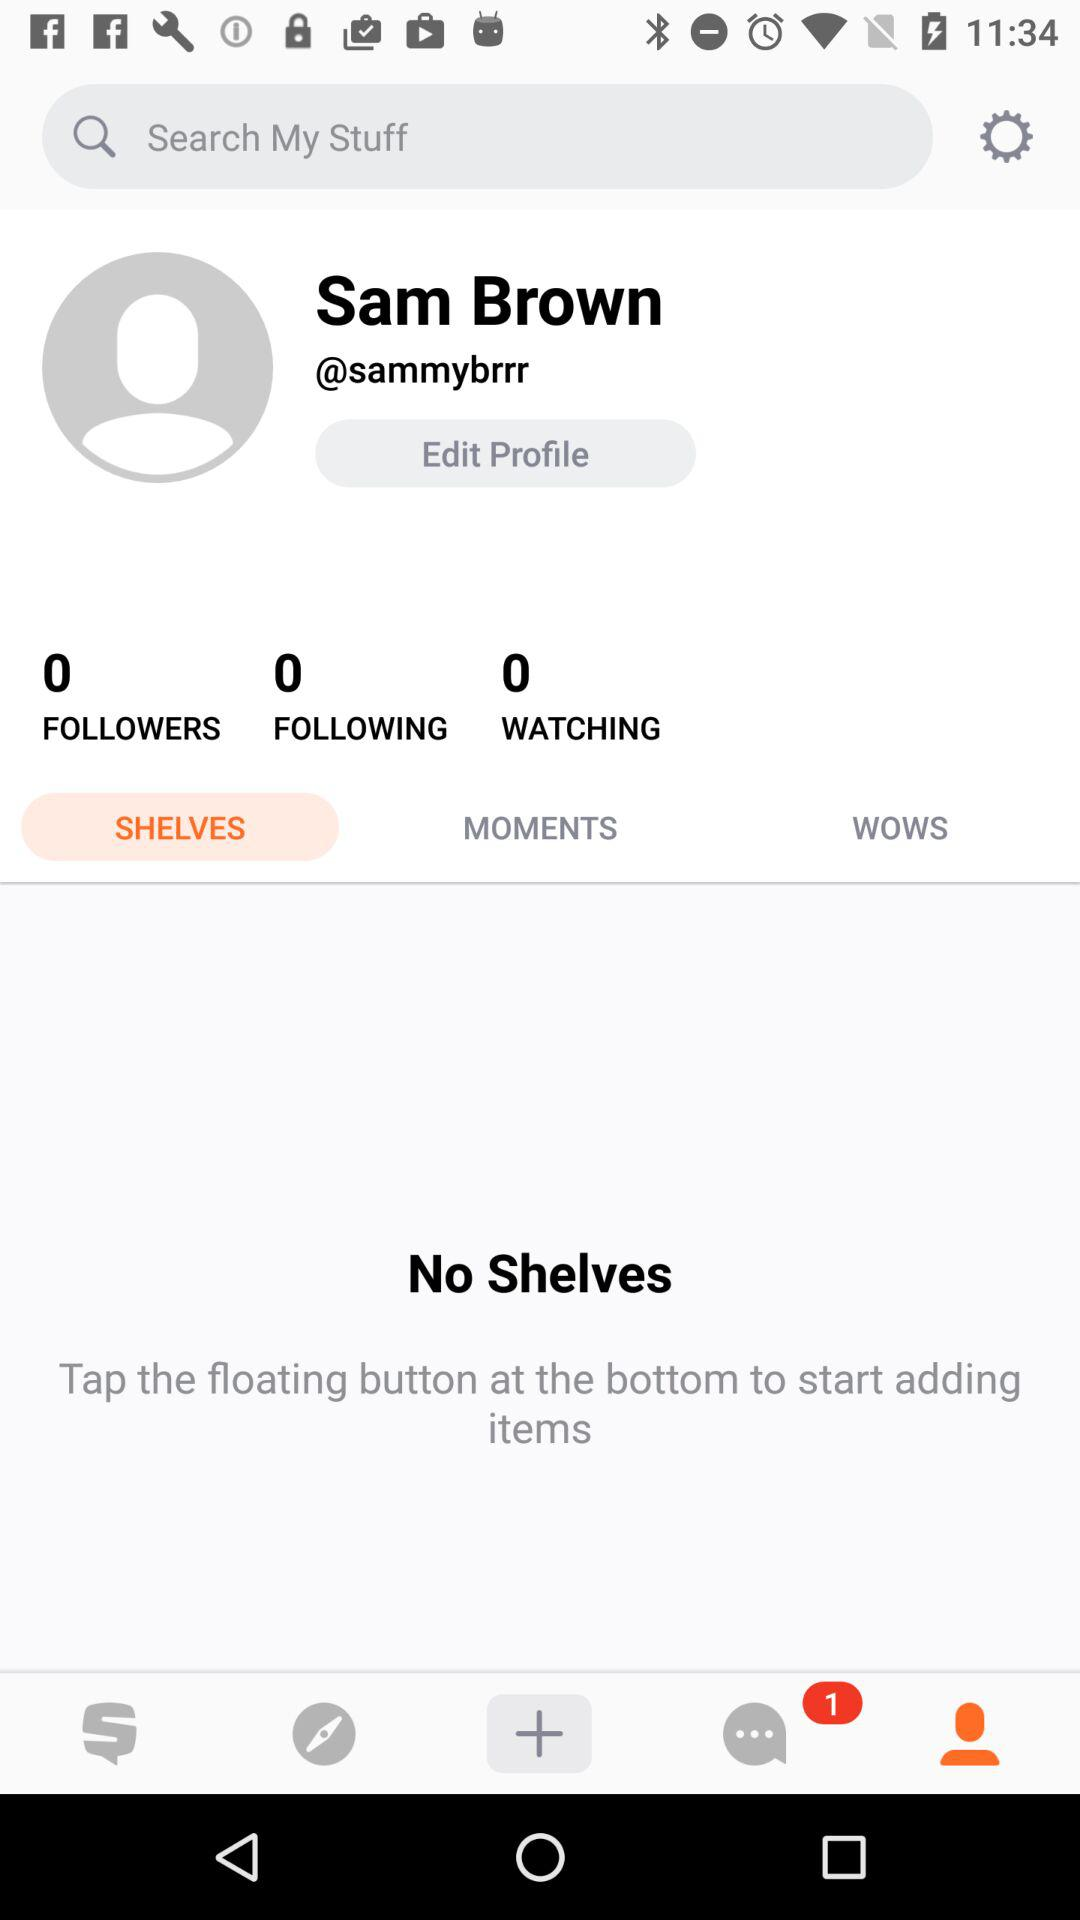What is the user name? The user name is Sam Brown. 